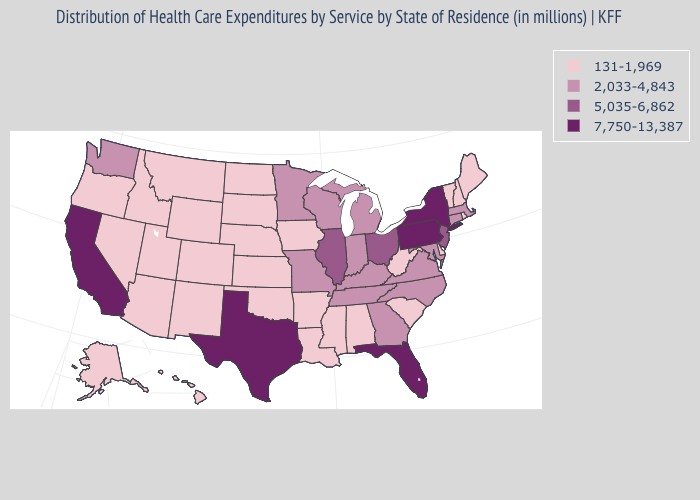Does Michigan have the lowest value in the USA?
Write a very short answer. No. Does the map have missing data?
Answer briefly. No. What is the value of Indiana?
Give a very brief answer. 2,033-4,843. Does Georgia have the same value as Tennessee?
Short answer required. Yes. Name the states that have a value in the range 7,750-13,387?
Give a very brief answer. California, Florida, New York, Pennsylvania, Texas. What is the value of Vermont?
Answer briefly. 131-1,969. Which states have the lowest value in the West?
Answer briefly. Alaska, Arizona, Colorado, Hawaii, Idaho, Montana, Nevada, New Mexico, Oregon, Utah, Wyoming. Does Kentucky have the same value as Connecticut?
Keep it brief. Yes. What is the value of Massachusetts?
Be succinct. 2,033-4,843. What is the lowest value in the MidWest?
Concise answer only. 131-1,969. What is the lowest value in the USA?
Concise answer only. 131-1,969. Name the states that have a value in the range 131-1,969?
Give a very brief answer. Alabama, Alaska, Arizona, Arkansas, Colorado, Delaware, Hawaii, Idaho, Iowa, Kansas, Louisiana, Maine, Mississippi, Montana, Nebraska, Nevada, New Hampshire, New Mexico, North Dakota, Oklahoma, Oregon, Rhode Island, South Carolina, South Dakota, Utah, Vermont, West Virginia, Wyoming. What is the value of Florida?
Be succinct. 7,750-13,387. What is the value of Kansas?
Answer briefly. 131-1,969. 